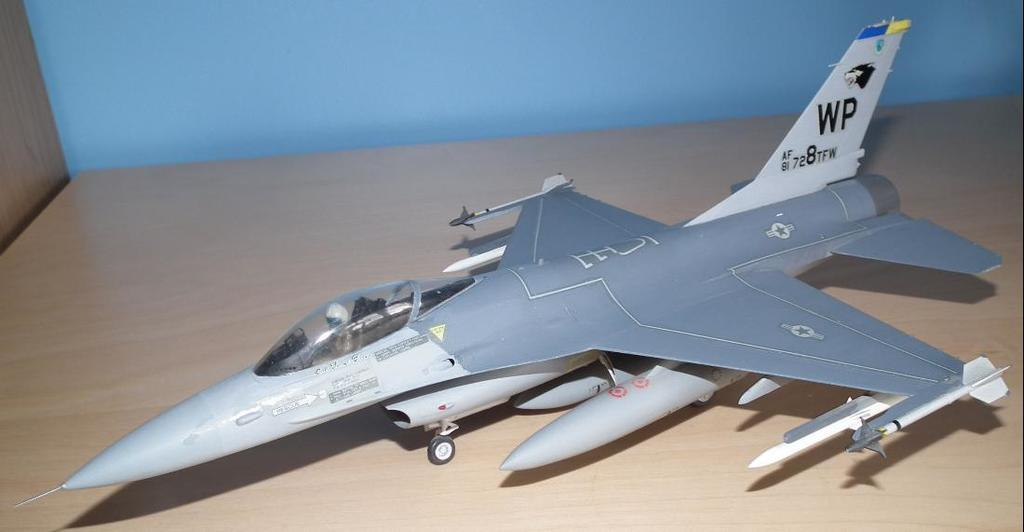<image>
Render a clear and concise summary of the photo. a model airplane with the letter WP on the tail is sitting on a table 